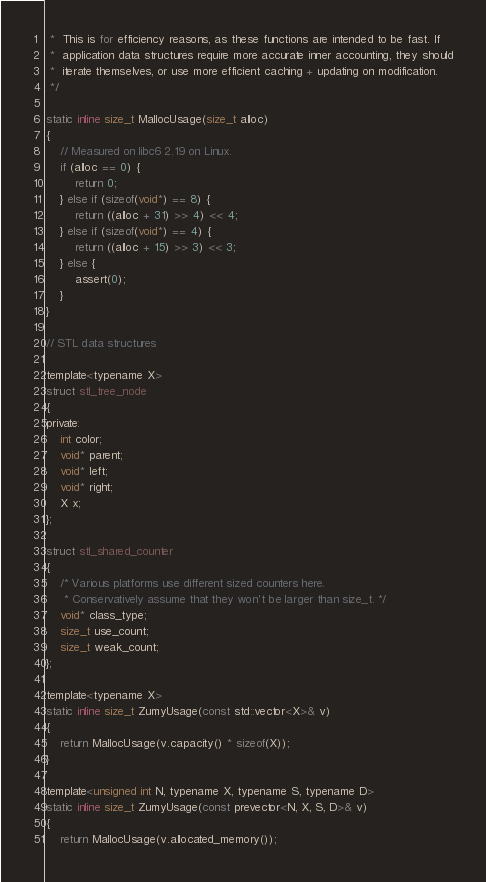<code> <loc_0><loc_0><loc_500><loc_500><_C_> *  This is for efficiency reasons, as these functions are intended to be fast. If
 *  application data structures require more accurate inner accounting, they should
 *  iterate themselves, or use more efficient caching + updating on modification.
 */

static inline size_t MallocUsage(size_t alloc)
{
    // Measured on libc6 2.19 on Linux.
    if (alloc == 0) {
        return 0;
    } else if (sizeof(void*) == 8) {
        return ((alloc + 31) >> 4) << 4;
    } else if (sizeof(void*) == 4) {
        return ((alloc + 15) >> 3) << 3;
    } else {
        assert(0);
    }
}

// STL data structures

template<typename X>
struct stl_tree_node
{
private:
    int color;
    void* parent;
    void* left;
    void* right;
    X x;
};

struct stl_shared_counter
{
    /* Various platforms use different sized counters here.
     * Conservatively assume that they won't be larger than size_t. */
    void* class_type;
    size_t use_count;
    size_t weak_count;
};

template<typename X>
static inline size_t ZumyUsage(const std::vector<X>& v)
{
    return MallocUsage(v.capacity() * sizeof(X));
}

template<unsigned int N, typename X, typename S, typename D>
static inline size_t ZumyUsage(const prevector<N, X, S, D>& v)
{
    return MallocUsage(v.allocated_memory());</code> 